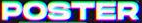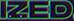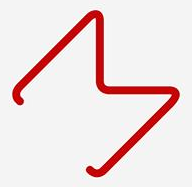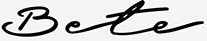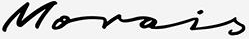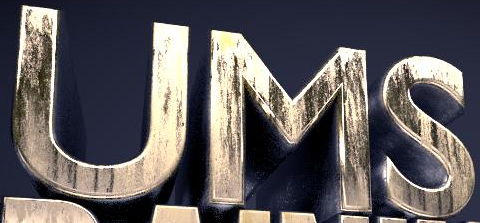Transcribe the words shown in these images in order, separated by a semicolon. POSTER; IZED; M; Bete; Morois; UMS 